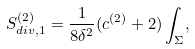Convert formula to latex. <formula><loc_0><loc_0><loc_500><loc_500>S _ { d i v , 1 } ^ { ( 2 ) } = \frac { 1 } { 8 \delta ^ { 2 } } ( c ^ { ( 2 ) } + 2 ) \int _ { \Sigma } ,</formula> 